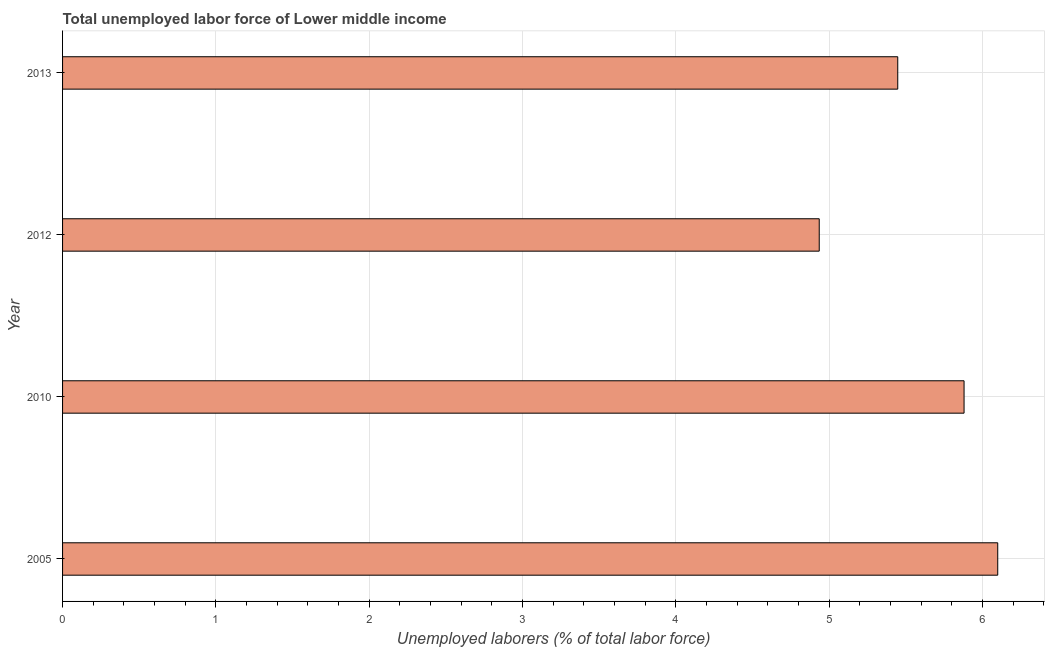What is the title of the graph?
Your response must be concise. Total unemployed labor force of Lower middle income. What is the label or title of the X-axis?
Provide a succinct answer. Unemployed laborers (% of total labor force). What is the total unemployed labour force in 2012?
Your answer should be very brief. 4.93. Across all years, what is the maximum total unemployed labour force?
Ensure brevity in your answer.  6.1. Across all years, what is the minimum total unemployed labour force?
Your answer should be very brief. 4.93. In which year was the total unemployed labour force minimum?
Ensure brevity in your answer.  2012. What is the sum of the total unemployed labour force?
Offer a very short reply. 22.36. What is the difference between the total unemployed labour force in 2010 and 2012?
Your answer should be very brief. 0.94. What is the average total unemployed labour force per year?
Give a very brief answer. 5.59. What is the median total unemployed labour force?
Provide a succinct answer. 5.66. In how many years, is the total unemployed labour force greater than 6 %?
Your answer should be very brief. 1. What is the ratio of the total unemployed labour force in 2005 to that in 2010?
Provide a short and direct response. 1.04. Is the total unemployed labour force in 2012 less than that in 2013?
Your answer should be compact. Yes. Is the difference between the total unemployed labour force in 2005 and 2012 greater than the difference between any two years?
Keep it short and to the point. Yes. What is the difference between the highest and the second highest total unemployed labour force?
Offer a very short reply. 0.22. What is the difference between the highest and the lowest total unemployed labour force?
Keep it short and to the point. 1.16. How many bars are there?
Your answer should be very brief. 4. Are all the bars in the graph horizontal?
Keep it short and to the point. Yes. How many years are there in the graph?
Make the answer very short. 4. What is the difference between two consecutive major ticks on the X-axis?
Your response must be concise. 1. Are the values on the major ticks of X-axis written in scientific E-notation?
Your response must be concise. No. What is the Unemployed laborers (% of total labor force) in 2005?
Ensure brevity in your answer.  6.1. What is the Unemployed laborers (% of total labor force) in 2010?
Your response must be concise. 5.88. What is the Unemployed laborers (% of total labor force) of 2012?
Provide a succinct answer. 4.93. What is the Unemployed laborers (% of total labor force) of 2013?
Offer a terse response. 5.45. What is the difference between the Unemployed laborers (% of total labor force) in 2005 and 2010?
Your answer should be compact. 0.22. What is the difference between the Unemployed laborers (% of total labor force) in 2005 and 2012?
Make the answer very short. 1.16. What is the difference between the Unemployed laborers (% of total labor force) in 2005 and 2013?
Provide a short and direct response. 0.65. What is the difference between the Unemployed laborers (% of total labor force) in 2010 and 2012?
Ensure brevity in your answer.  0.94. What is the difference between the Unemployed laborers (% of total labor force) in 2010 and 2013?
Offer a terse response. 0.43. What is the difference between the Unemployed laborers (% of total labor force) in 2012 and 2013?
Your answer should be compact. -0.51. What is the ratio of the Unemployed laborers (% of total labor force) in 2005 to that in 2010?
Your response must be concise. 1.04. What is the ratio of the Unemployed laborers (% of total labor force) in 2005 to that in 2012?
Keep it short and to the point. 1.24. What is the ratio of the Unemployed laborers (% of total labor force) in 2005 to that in 2013?
Keep it short and to the point. 1.12. What is the ratio of the Unemployed laborers (% of total labor force) in 2010 to that in 2012?
Your response must be concise. 1.19. What is the ratio of the Unemployed laborers (% of total labor force) in 2010 to that in 2013?
Your answer should be compact. 1.08. What is the ratio of the Unemployed laborers (% of total labor force) in 2012 to that in 2013?
Offer a very short reply. 0.91. 